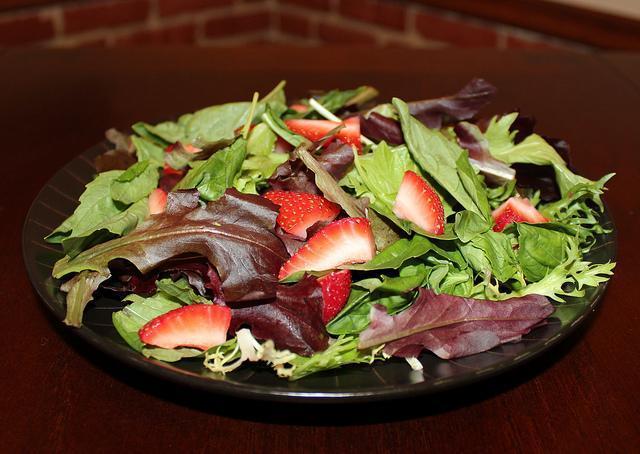How many different ingredients are in the salad?
Give a very brief answer. 3. How many different toppings does the salad have?
Give a very brief answer. 1. How many cars are to the left of the carriage?
Give a very brief answer. 0. 